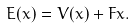<formula> <loc_0><loc_0><loc_500><loc_500>E ( x ) = V ( x ) + F x .</formula> 